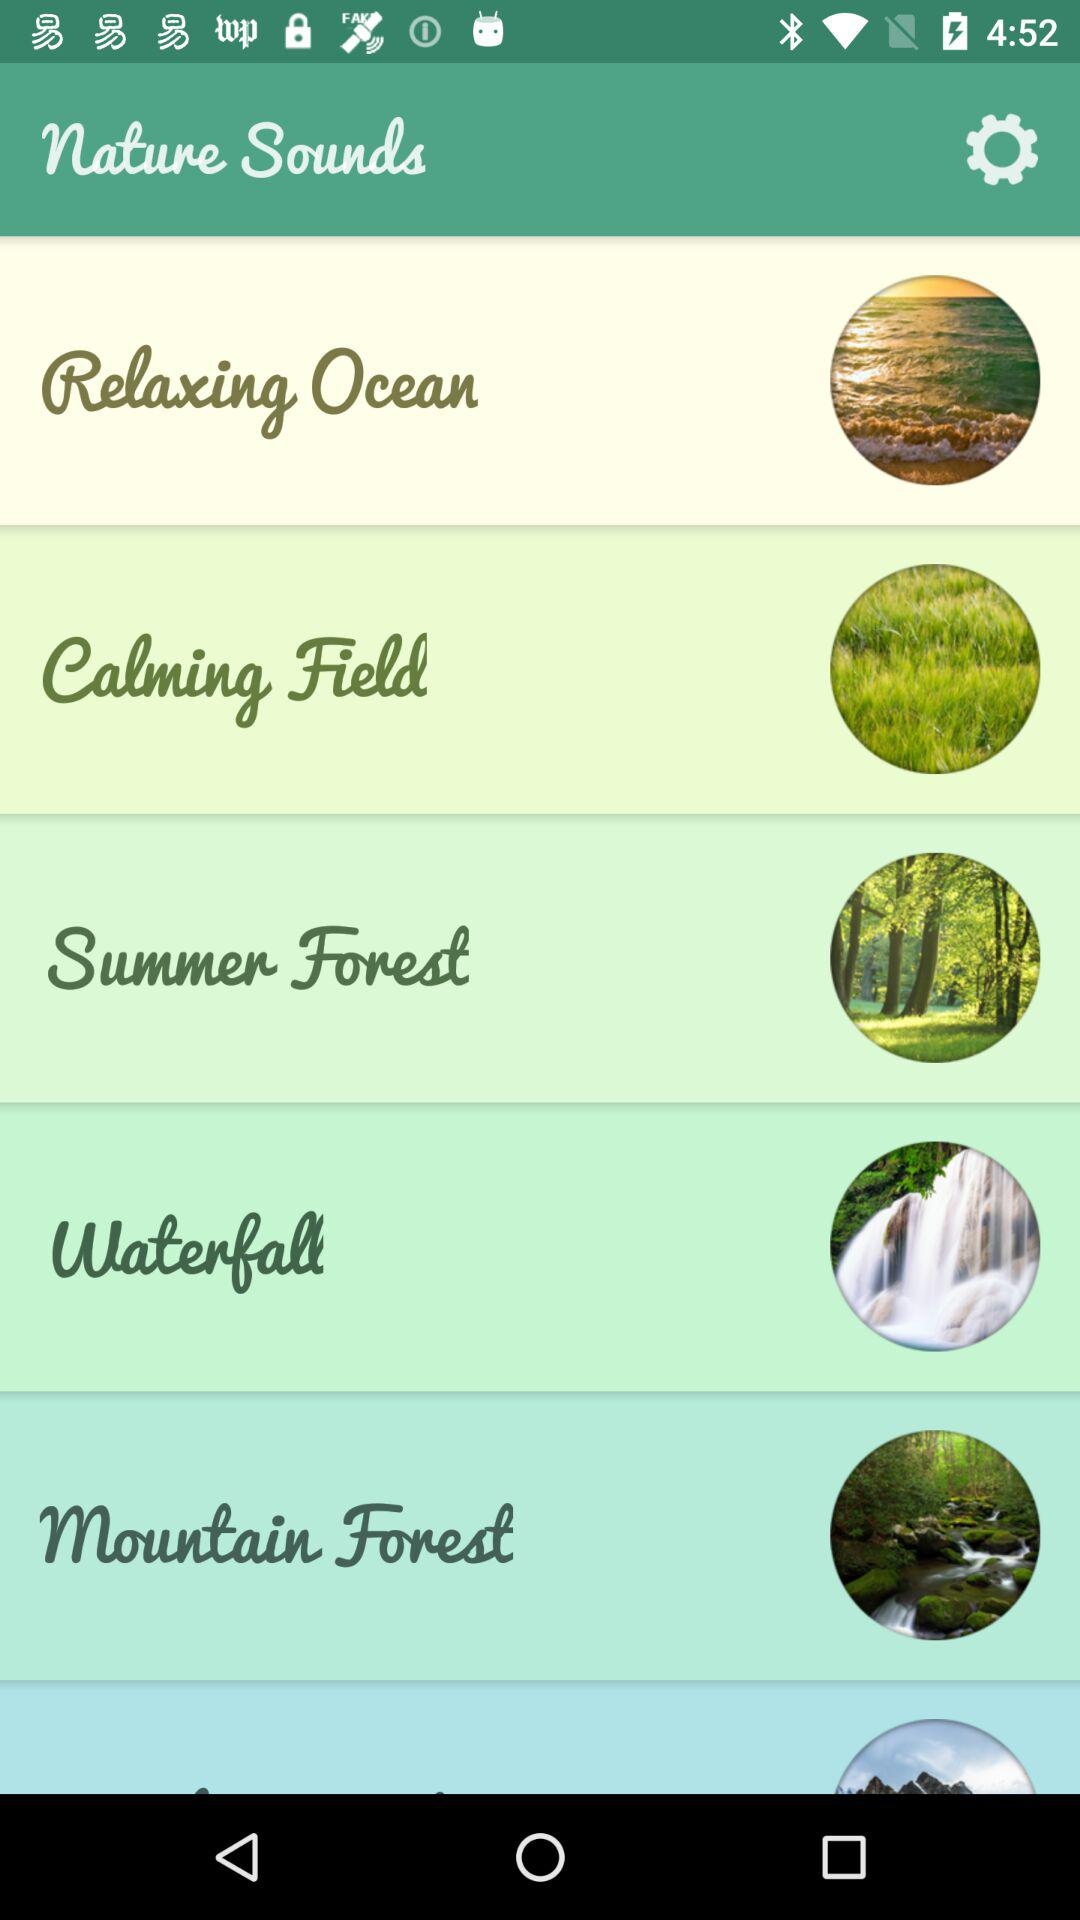What is the application name? The application name is "Nature Sounds". 